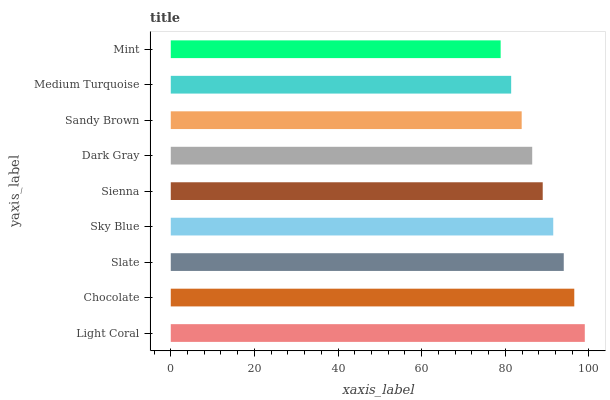Is Mint the minimum?
Answer yes or no. Yes. Is Light Coral the maximum?
Answer yes or no. Yes. Is Chocolate the minimum?
Answer yes or no. No. Is Chocolate the maximum?
Answer yes or no. No. Is Light Coral greater than Chocolate?
Answer yes or no. Yes. Is Chocolate less than Light Coral?
Answer yes or no. Yes. Is Chocolate greater than Light Coral?
Answer yes or no. No. Is Light Coral less than Chocolate?
Answer yes or no. No. Is Sienna the high median?
Answer yes or no. Yes. Is Sienna the low median?
Answer yes or no. Yes. Is Dark Gray the high median?
Answer yes or no. No. Is Sandy Brown the low median?
Answer yes or no. No. 